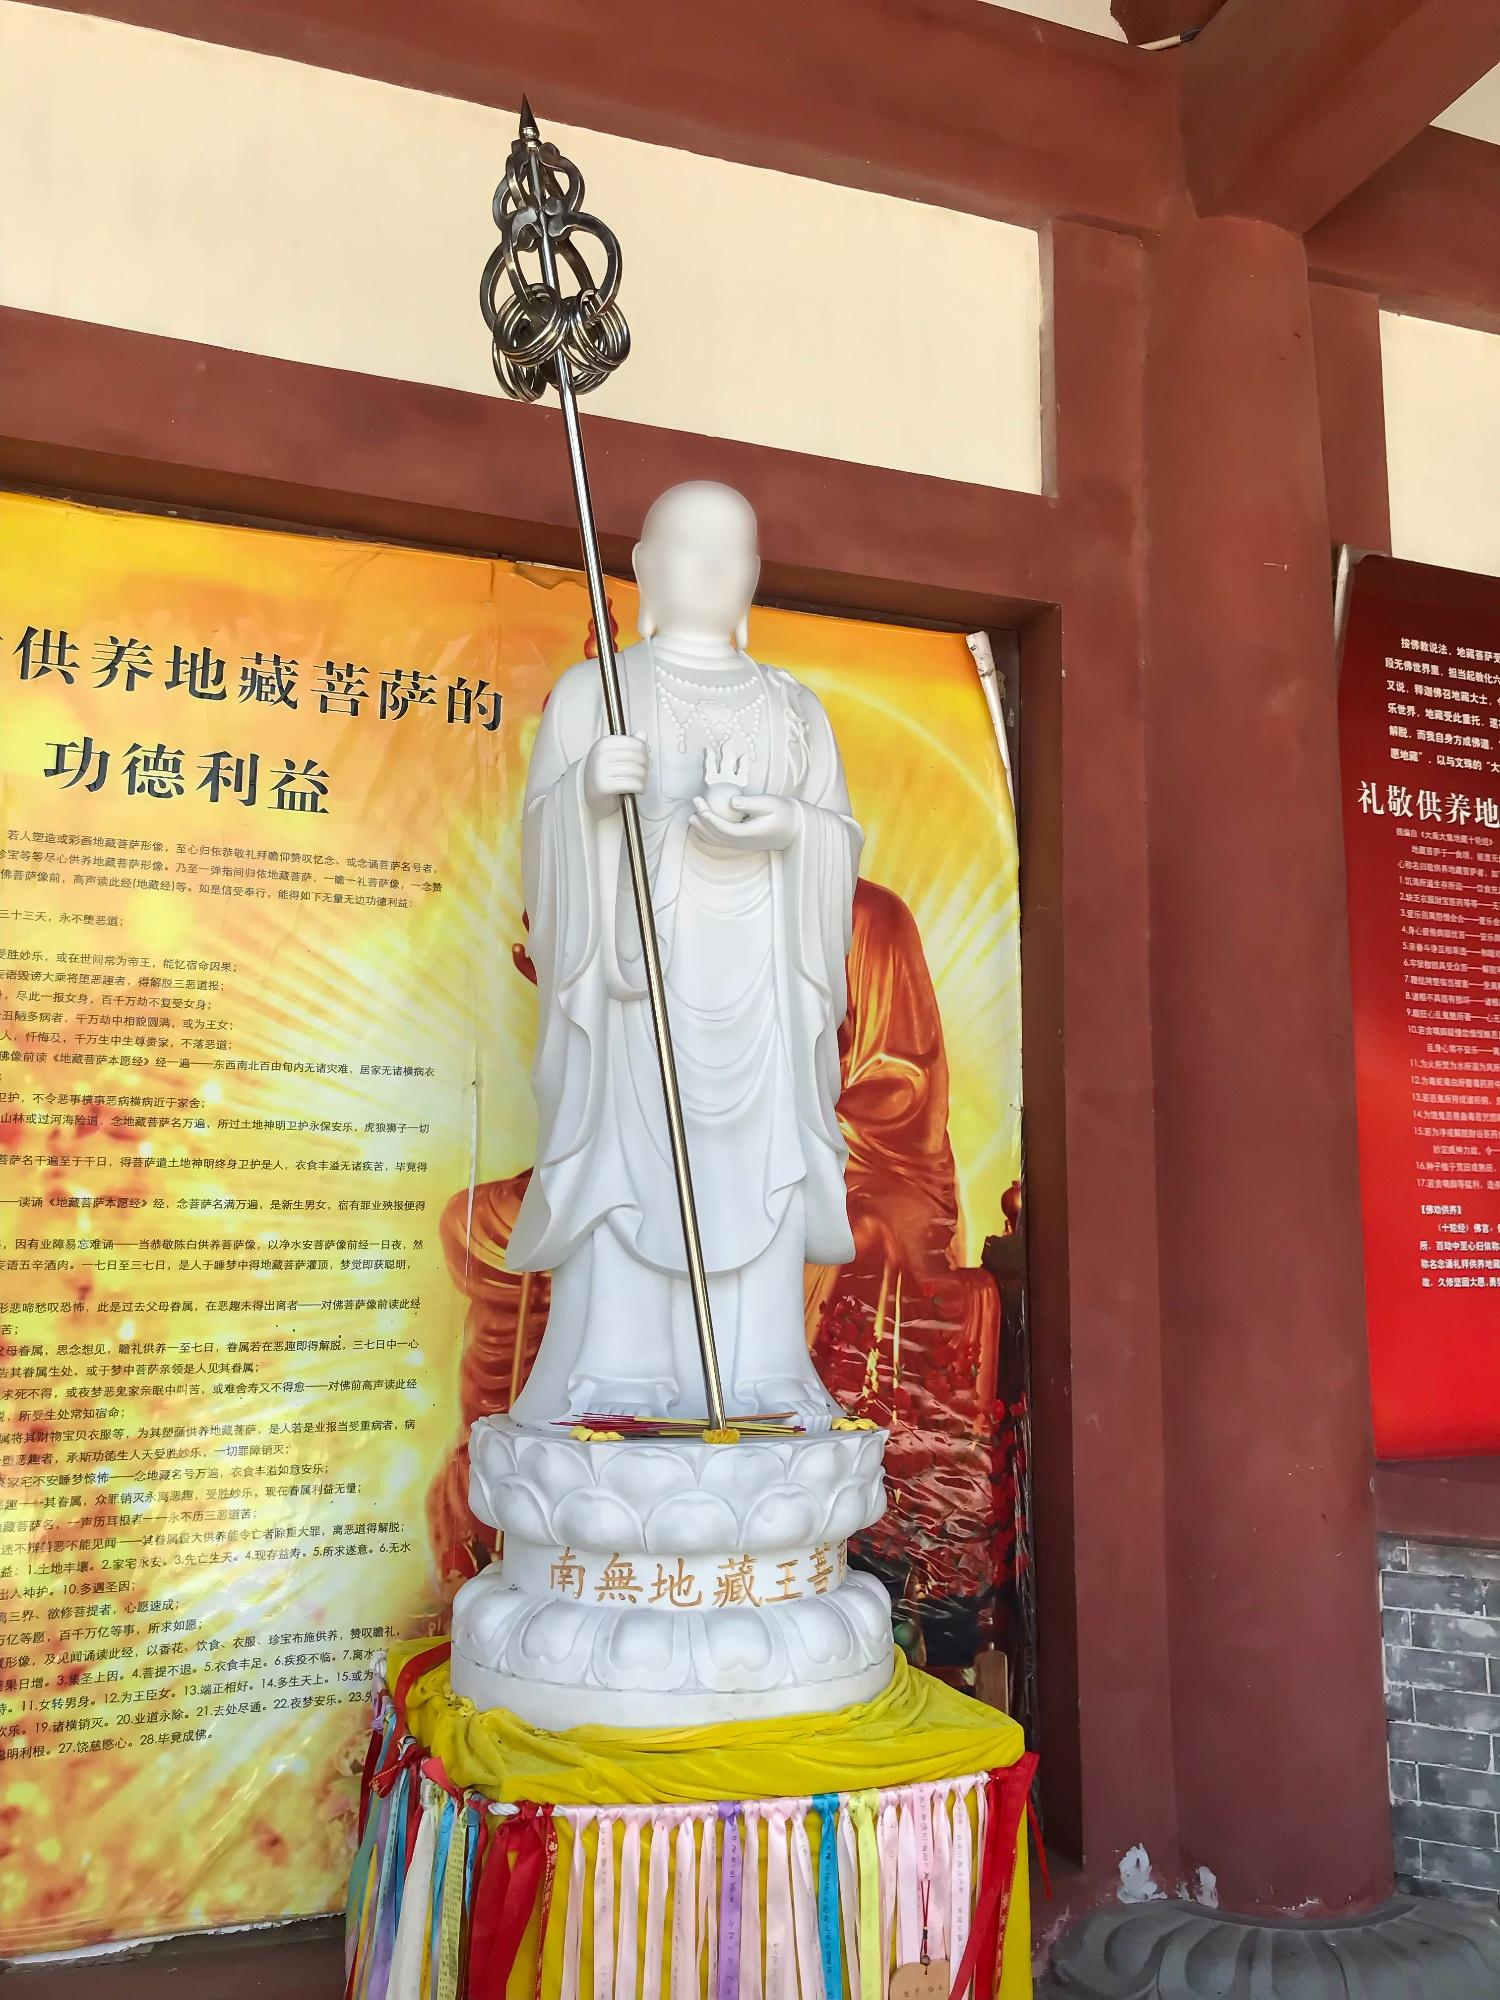What can you infer about the setting where this statue is located? The statue is likely situated within a temple or a place of worship, as indicated by the traditional elements and spiritual symbolism present. The decorative script on the banners and pedestal suggests that it is a space where Chinese scriptural and cultural influence is significant. The meticulous arrangement and the serene expression of the statue imply a setting that is dedicated to contemplation, meditation, and reverence. Such a location is probably a site for religious gatherings, rituals, and a focal point for devotees to offer their respect and seek blessings. 